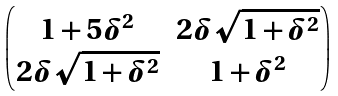Convert formula to latex. <formula><loc_0><loc_0><loc_500><loc_500>\begin{pmatrix} 1 + 5 \delta ^ { 2 } & 2 \delta \sqrt { 1 + \delta ^ { 2 } } \\ 2 \delta \sqrt { 1 + \delta ^ { 2 } } & 1 + \delta ^ { 2 } \end{pmatrix}</formula> 